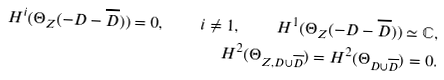Convert formula to latex. <formula><loc_0><loc_0><loc_500><loc_500>H ^ { i } ( \Theta _ { Z } ( - D - \overline { D } ) ) = 0 , \quad i \neq 1 , \quad H ^ { 1 } ( \Theta _ { Z } ( - D - \overline { D } ) ) \simeq \mathbb { C } , \\ H ^ { 2 } ( \Theta _ { Z , D \cup \overline { D } } ) = H ^ { 2 } ( \Theta _ { D \cup \overline { D } } ) = 0 .</formula> 